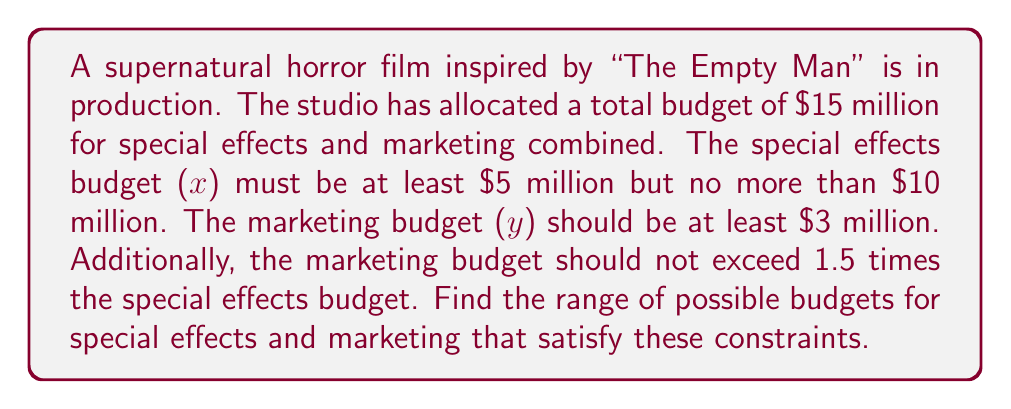Give your solution to this math problem. Let's solve this system of inequalities step by step:

1. Define the variables:
   $x$ = special effects budget (in millions)
   $y$ = marketing budget (in millions)

2. Write out the inequalities:
   $x + y \leq 15$ (total budget constraint)
   $5 \leq x \leq 10$ (special effects budget constraints)
   $y \geq 3$ (minimum marketing budget)
   $y \leq 1.5x$ (marketing budget not exceeding 1.5 times special effects)

3. Combine the inequalities:
   $$\begin{cases}
   x + y \leq 15 \\
   5 \leq x \leq 10 \\
   y \geq 3 \\
   y \leq 1.5x
   \end{cases}$$

4. Plot these inequalities on a coordinate plane:
   [asy]
   import graph;
   size(200);
   xaxis("x", 0, 12);
   yaxis("y", 0, 15);
   draw((5,0)--(5,15), gray);
   draw((10,0)--(10,15), gray);
   draw((0,3)--(15,3), gray);
   draw((0,0)--(10,15), gray);
   draw((0,15)--(15,0), gray);
   fill((5,3)--(5,7.5)--(6.67,10)--(10,10)--(10,5)--(7,3)--cycle, palegreen);
   label("Feasible Region", (7,6), S);
   [/asy]

5. The feasible region is the shaded area that satisfies all inequalities.

6. Find the vertices of the feasible region:
   (5, 3), (5, 7.5), (6.67, 10), (10, 10), (10, 5), (7, 3)

7. The range for x (special effects budget) is from 5 to 10 million.
   The range for y (marketing budget) is from 3 to 10 million.
Answer: Special effects: $[5, 10]$ million; Marketing: $[3, 10]$ million 